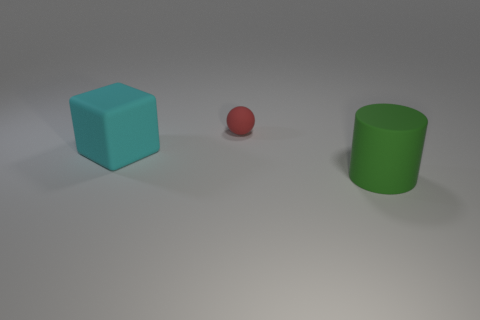Subtract 0 yellow blocks. How many objects are left? 3 Subtract all cubes. How many objects are left? 2 Subtract 1 spheres. How many spheres are left? 0 Subtract all gray cylinders. Subtract all gray blocks. How many cylinders are left? 1 Subtract all tiny blue matte cylinders. Subtract all small things. How many objects are left? 2 Add 3 green objects. How many green objects are left? 4 Add 3 big matte cubes. How many big matte cubes exist? 4 Add 1 green cylinders. How many objects exist? 4 